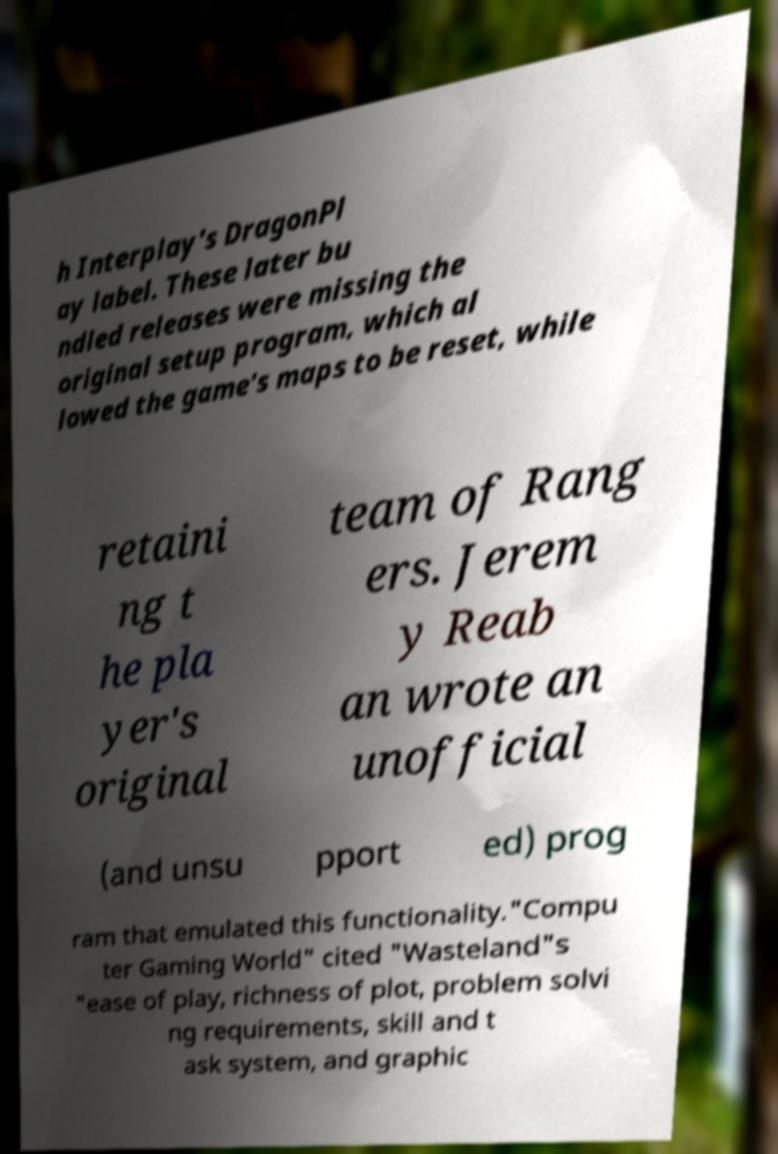What messages or text are displayed in this image? I need them in a readable, typed format. h Interplay's DragonPl ay label. These later bu ndled releases were missing the original setup program, which al lowed the game's maps to be reset, while retaini ng t he pla yer's original team of Rang ers. Jerem y Reab an wrote an unofficial (and unsu pport ed) prog ram that emulated this functionality."Compu ter Gaming World" cited "Wasteland"s "ease of play, richness of plot, problem solvi ng requirements, skill and t ask system, and graphic 